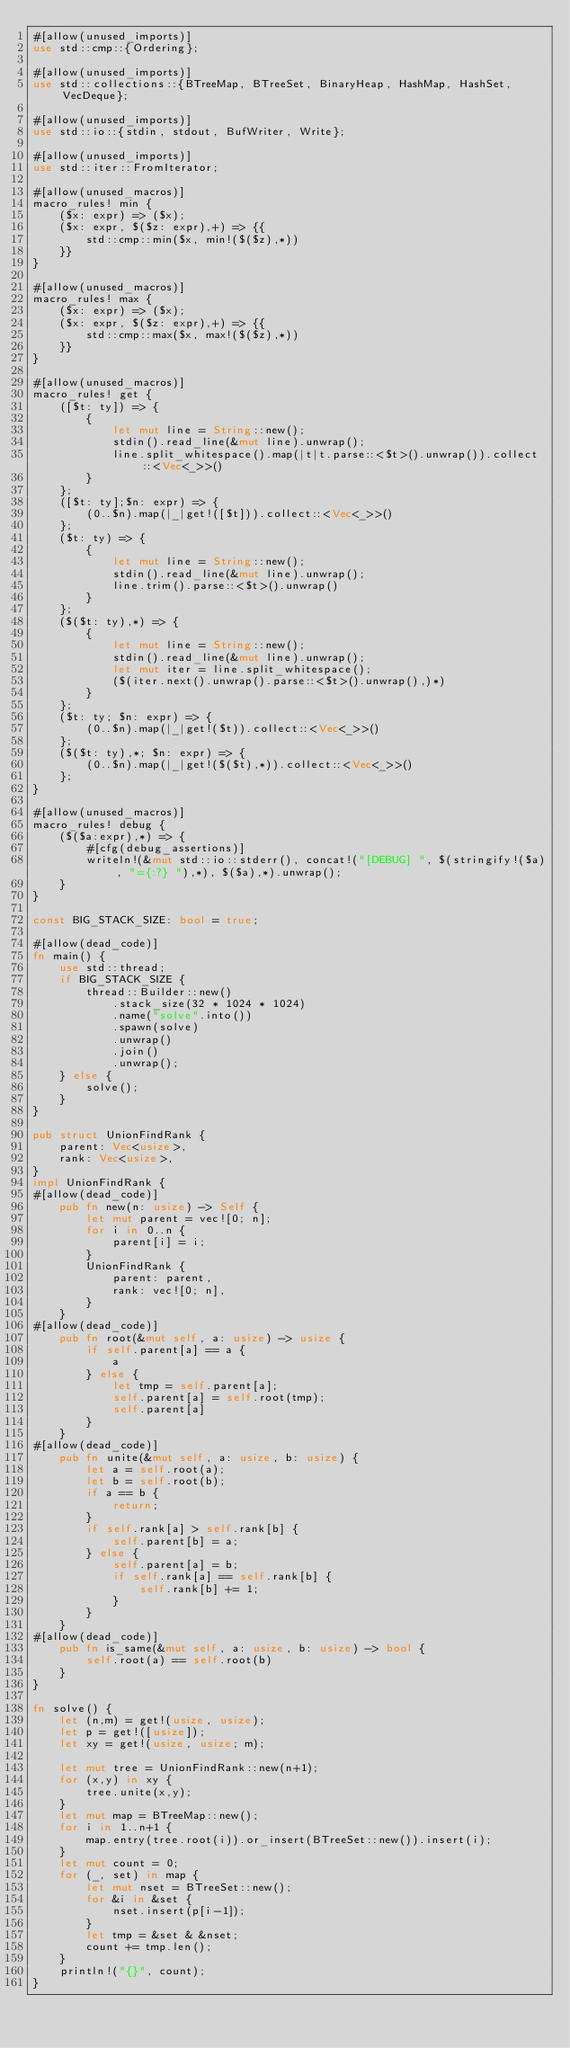<code> <loc_0><loc_0><loc_500><loc_500><_Rust_>#[allow(unused_imports)]
use std::cmp::{Ordering};

#[allow(unused_imports)]
use std::collections::{BTreeMap, BTreeSet, BinaryHeap, HashMap, HashSet, VecDeque};

#[allow(unused_imports)]
use std::io::{stdin, stdout, BufWriter, Write};

#[allow(unused_imports)]
use std::iter::FromIterator;

#[allow(unused_macros)]
macro_rules! min {
    ($x: expr) => ($x);
    ($x: expr, $($z: expr),+) => {{
        std::cmp::min($x, min!($($z),*))
    }}
}

#[allow(unused_macros)]
macro_rules! max {
    ($x: expr) => ($x);
    ($x: expr, $($z: expr),+) => {{
        std::cmp::max($x, max!($($z),*))
    }}
}

#[allow(unused_macros)]
macro_rules! get { 
    ([$t: ty]) => { 
        { 
            let mut line = String::new(); 
            stdin().read_line(&mut line).unwrap(); 
            line.split_whitespace().map(|t|t.parse::<$t>().unwrap()).collect::<Vec<_>>()
        }
    };
    ([$t: ty];$n: expr) => {
        (0..$n).map(|_|get!([$t])).collect::<Vec<_>>()
    };
    ($t: ty) => {
        {
            let mut line = String::new();
            stdin().read_line(&mut line).unwrap();
            line.trim().parse::<$t>().unwrap()
        }
    };
    ($($t: ty),*) => {
        { 
            let mut line = String::new();
            stdin().read_line(&mut line).unwrap();
            let mut iter = line.split_whitespace();
            ($(iter.next().unwrap().parse::<$t>().unwrap(),)*)
        }
    };
    ($t: ty; $n: expr) => {
        (0..$n).map(|_|get!($t)).collect::<Vec<_>>()
    };
    ($($t: ty),*; $n: expr) => {
        (0..$n).map(|_|get!($($t),*)).collect::<Vec<_>>()
    };
}

#[allow(unused_macros)]
macro_rules! debug {
    ($($a:expr),*) => {
        #[cfg(debug_assertions)]
        writeln!(&mut std::io::stderr(), concat!("[DEBUG] ", $(stringify!($a), "={:?} "),*), $($a),*).unwrap();
    }
}

const BIG_STACK_SIZE: bool = true;

#[allow(dead_code)]
fn main() {
    use std::thread;
    if BIG_STACK_SIZE {
        thread::Builder::new()
            .stack_size(32 * 1024 * 1024)
            .name("solve".into())
            .spawn(solve)
            .unwrap()
            .join()
            .unwrap();
    } else {
        solve();
    }
}

pub struct UnionFindRank {
    parent: Vec<usize>,
    rank: Vec<usize>,
}
impl UnionFindRank {
#[allow(dead_code)]
    pub fn new(n: usize) -> Self {
        let mut parent = vec![0; n];
        for i in 0..n {
            parent[i] = i;
        }
        UnionFindRank {
            parent: parent,
            rank: vec![0; n],
        }
    }
#[allow(dead_code)]
    pub fn root(&mut self, a: usize) -> usize {
        if self.parent[a] == a {
            a
        } else {
            let tmp = self.parent[a];
            self.parent[a] = self.root(tmp);
            self.parent[a]
        }
    }
#[allow(dead_code)]
    pub fn unite(&mut self, a: usize, b: usize) {
        let a = self.root(a);
        let b = self.root(b);
        if a == b {
            return;
        }
        if self.rank[a] > self.rank[b] {
            self.parent[b] = a;
        } else {
            self.parent[a] = b;
            if self.rank[a] == self.rank[b] {
                self.rank[b] += 1;
            }
        }
    }
#[allow(dead_code)]
    pub fn is_same(&mut self, a: usize, b: usize) -> bool {
        self.root(a) == self.root(b)
    }
}

fn solve() {
    let (n,m) = get!(usize, usize);
    let p = get!([usize]);
    let xy = get!(usize, usize; m);

    let mut tree = UnionFindRank::new(n+1);
    for (x,y) in xy {
        tree.unite(x,y);
    }
    let mut map = BTreeMap::new();
    for i in 1..n+1 {
        map.entry(tree.root(i)).or_insert(BTreeSet::new()).insert(i);
    }
    let mut count = 0;
    for (_, set) in map {
        let mut nset = BTreeSet::new();
        for &i in &set {
            nset.insert(p[i-1]);
        }
        let tmp = &set & &nset;
        count += tmp.len();
    }
    println!("{}", count);
}
</code> 